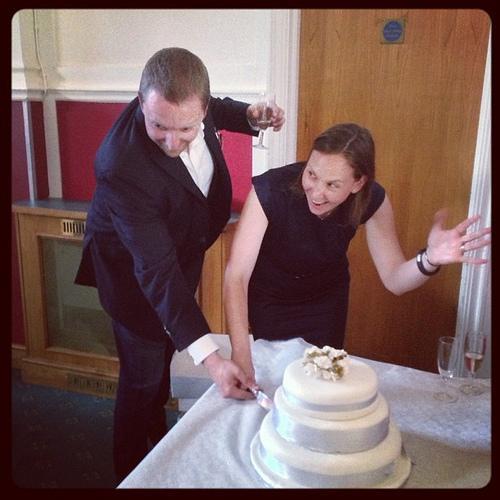How many people are there?
Give a very brief answer. 2. How many cakes are on the table?
Give a very brief answer. 1. 